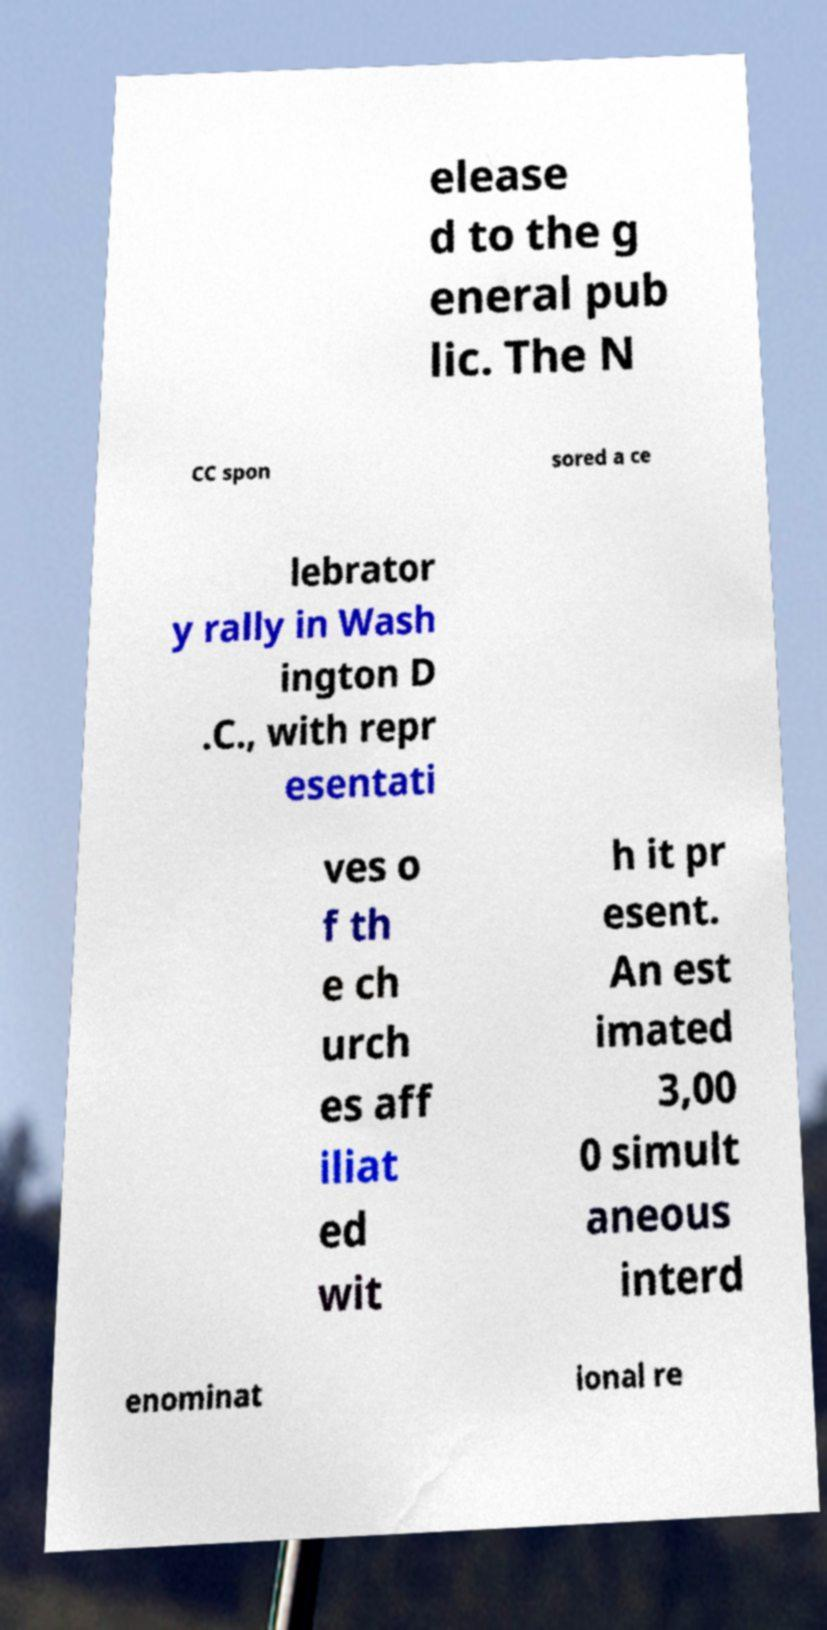I need the written content from this picture converted into text. Can you do that? elease d to the g eneral pub lic. The N CC spon sored a ce lebrator y rally in Wash ington D .C., with repr esentati ves o f th e ch urch es aff iliat ed wit h it pr esent. An est imated 3,00 0 simult aneous interd enominat ional re 